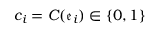<formula> <loc_0><loc_0><loc_500><loc_500>c _ { i } = C ( \mathfrak { e } _ { i } ) \in \{ 0 , 1 \}</formula> 